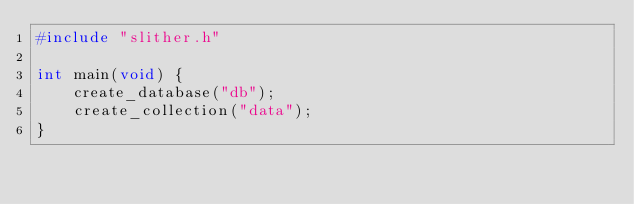Convert code to text. <code><loc_0><loc_0><loc_500><loc_500><_C_>#include "slither.h"

int main(void) {
    create_database("db");
    create_collection("data");
}</code> 